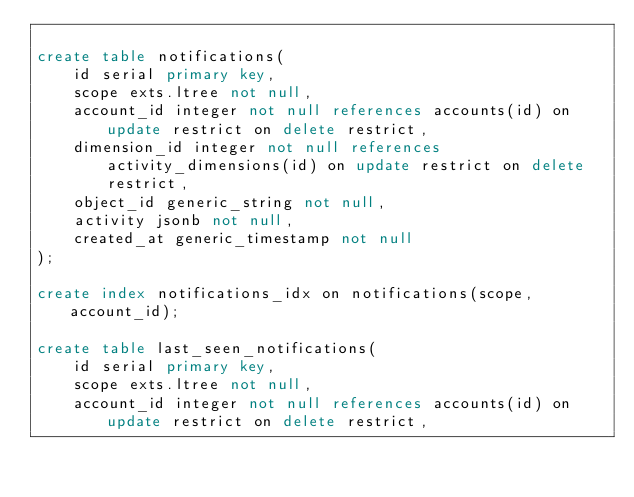Convert code to text. <code><loc_0><loc_0><loc_500><loc_500><_SQL_>
create table notifications(
    id serial primary key,
    scope exts.ltree not null,
    account_id integer not null references accounts(id) on update restrict on delete restrict,
    dimension_id integer not null references activity_dimensions(id) on update restrict on delete restrict,
    object_id generic_string not null,
    activity jsonb not null,
    created_at generic_timestamp not null
);

create index notifications_idx on notifications(scope, account_id);

create table last_seen_notifications(
    id serial primary key,
    scope exts.ltree not null,
    account_id integer not null references accounts(id) on update restrict on delete restrict,</code> 